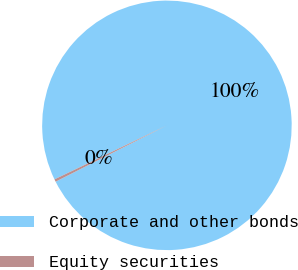Convert chart to OTSL. <chart><loc_0><loc_0><loc_500><loc_500><pie_chart><fcel>Corporate and other bonds<fcel>Equity securities<nl><fcel>99.67%<fcel>0.33%<nl></chart> 